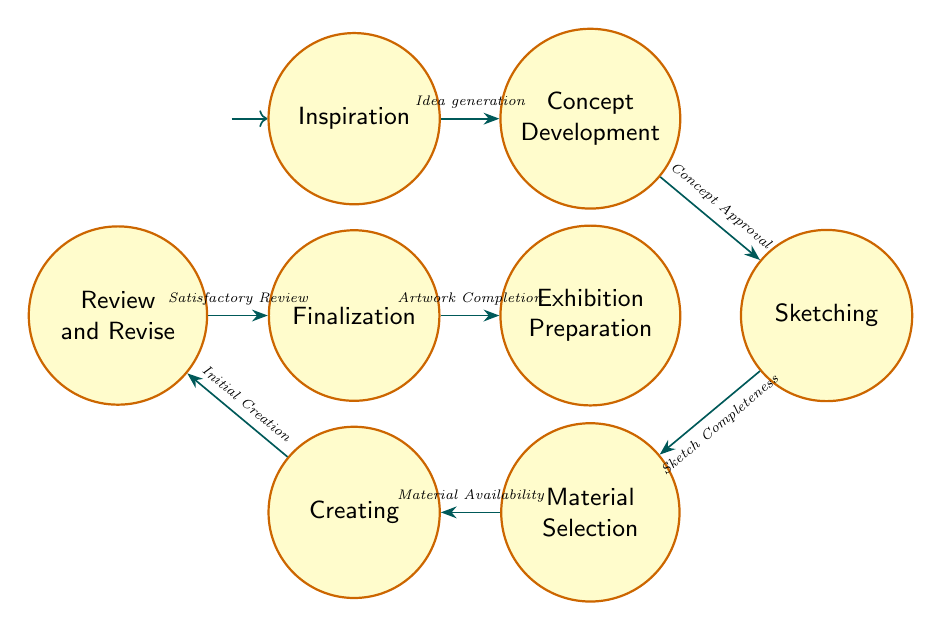What is the first state in the process? The first state in the diagram is "Inspiration." It’s the initial node where the creative process begins, marked as the starting point in the Finite State Machine.
Answer: Inspiration How many total states are there? There are a total of 8 states represented in the diagram, each corresponding to a different stage of the creative process, including Inspiration, Concept Development, Sketching, Material Selection, Creating, Review and Revise, Finalization, and Exhibition Preparation.
Answer: 8 What transition follows after "Material Selection"? After "Material Selection," the transition that follows is to "Creating," triggered by the "Material Availability." This indicates the progression from selecting materials to actually creating the artwork.
Answer: Creating Which state comes after "Review and Revise"? The state that follows "Review and Revise" is "Finalization." This transition occurs after achieving a "Satisfactory Review," indicating that the piece has been evaluated and approved for finishing touches.
Answer: Finalization What triggers the transition from "Creating" to "Review and Revise"? The transition from "Creating" to "Review and Revise" is triggered by "Initial Creation." This indicates that a draft or initial version of the artwork has been made and is now ready for review.
Answer: Initial Creation How many transitions are there in total? There are a total of 7 transitions in the diagram, indicating how one state leads to another through specific triggers within the creative process.
Answer: 7 What is the final state before exhibition? The final state before exhibition is "Finalization." Once this state is complete, the only step left is preparing the artwork for display.
Answer: Finalization Which state has the most transitions leading into it? The state with the most transitions leading into it is "Finalization," as it receives input from "Review and Revise" after achieving a satisfactory review.
Answer: Finalization 